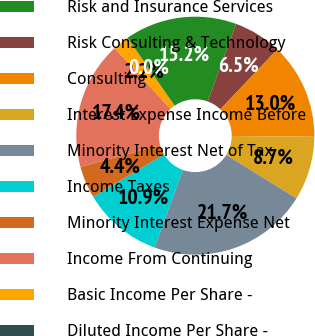Convert chart to OTSL. <chart><loc_0><loc_0><loc_500><loc_500><pie_chart><fcel>Risk and Insurance Services<fcel>Risk Consulting & Technology<fcel>Consulting<fcel>Interest Expense Income Before<fcel>Minority Interest Net of Tax<fcel>Income Taxes<fcel>Minority Interest Expense Net<fcel>Income From Continuing<fcel>Basic Income Per Share -<fcel>Diluted Income Per Share -<nl><fcel>15.2%<fcel>6.53%<fcel>13.04%<fcel>8.7%<fcel>21.71%<fcel>10.87%<fcel>4.36%<fcel>17.37%<fcel>2.19%<fcel>0.02%<nl></chart> 